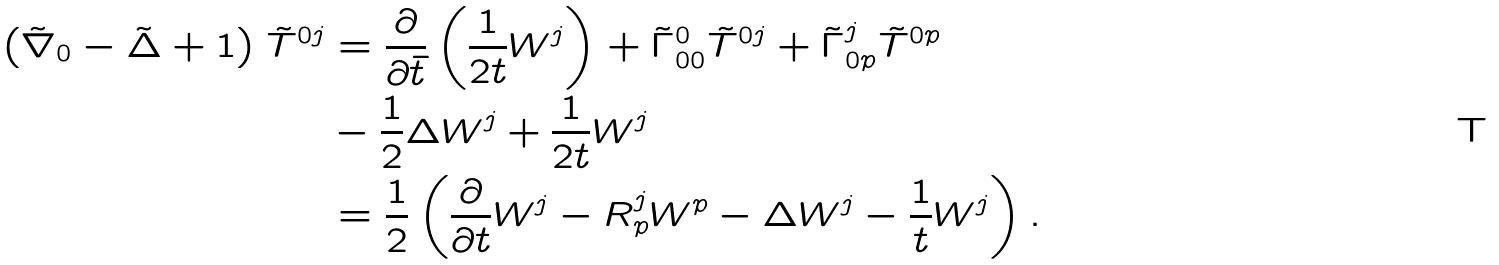<formula> <loc_0><loc_0><loc_500><loc_500>\left ( \tilde { \nabla } _ { 0 } - \tilde { \Delta } + 1 \right ) \tilde { T } ^ { 0 j } & = \frac { \partial } { \partial \bar { t } } \left ( \frac { 1 } { 2 t } W ^ { j } \right ) + \tilde { \Gamma } _ { 0 0 } ^ { 0 } \tilde { T } ^ { 0 j } + \tilde { \Gamma } _ { 0 p } ^ { j } \tilde { T } ^ { 0 p } \\ & - \frac { 1 } { 2 } \Delta W ^ { j } + \frac { 1 } { 2 t } W ^ { j } \\ & = \frac { 1 } { 2 } \left ( \frac { \partial } { \partial t } W ^ { j } - R _ { p } ^ { j } W ^ { p } - \Delta W ^ { j } - \frac { 1 } { t } W ^ { j } \right ) .</formula> 